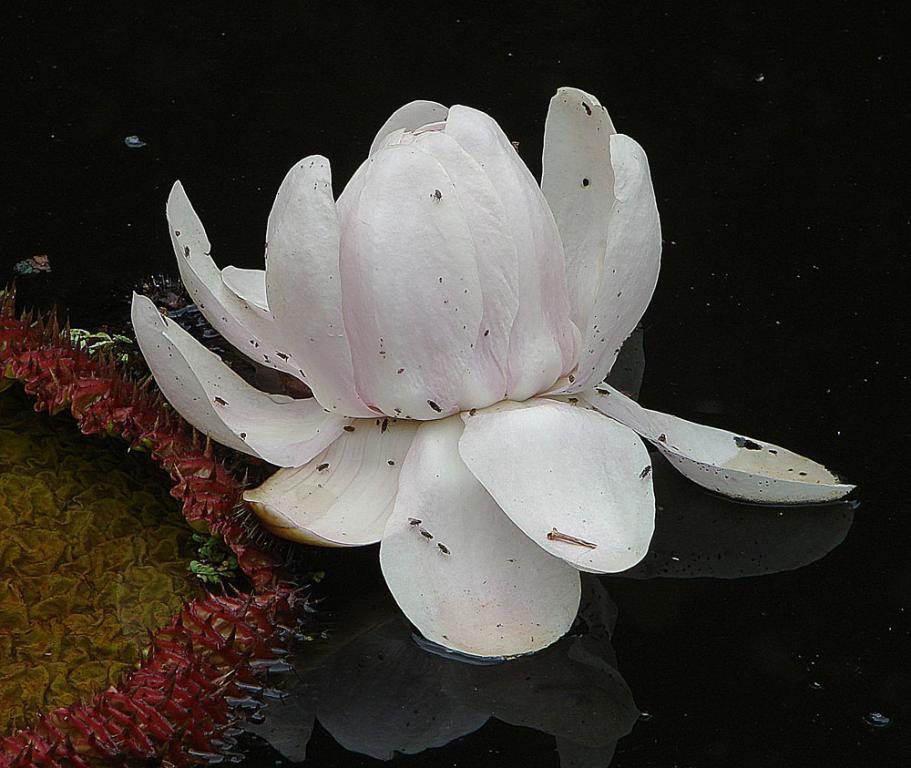In one or two sentences, can you explain what this image depicts? In this image we can see lotus which is in white color in the water pond and on left side of the image we can see some flowers which are in yellow and pink color. 